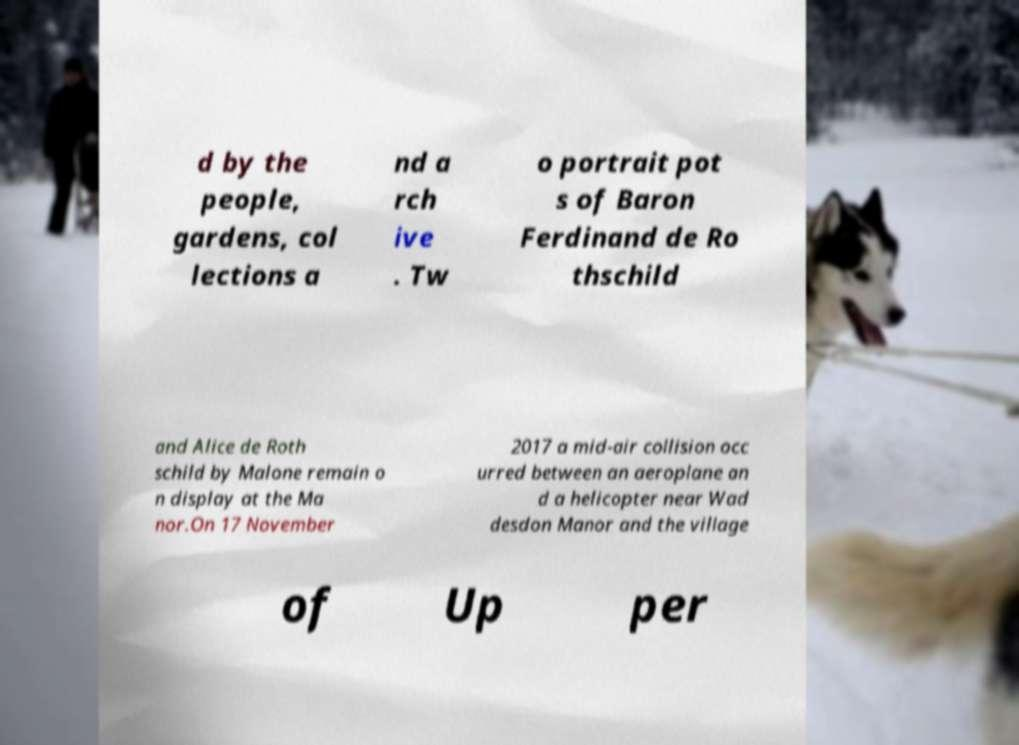Can you accurately transcribe the text from the provided image for me? d by the people, gardens, col lections a nd a rch ive . Tw o portrait pot s of Baron Ferdinand de Ro thschild and Alice de Roth schild by Malone remain o n display at the Ma nor.On 17 November 2017 a mid-air collision occ urred between an aeroplane an d a helicopter near Wad desdon Manor and the village of Up per 